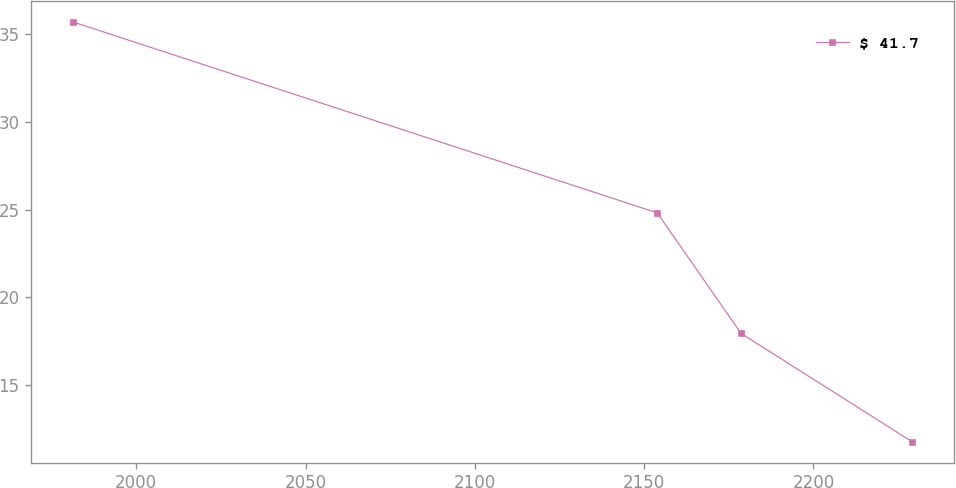Convert chart to OTSL. <chart><loc_0><loc_0><loc_500><loc_500><line_chart><ecel><fcel>$ 41.7<nl><fcel>1981.36<fcel>35.69<nl><fcel>2153.85<fcel>24.82<nl><fcel>2178.63<fcel>17.95<nl><fcel>2229.12<fcel>11.78<nl></chart> 